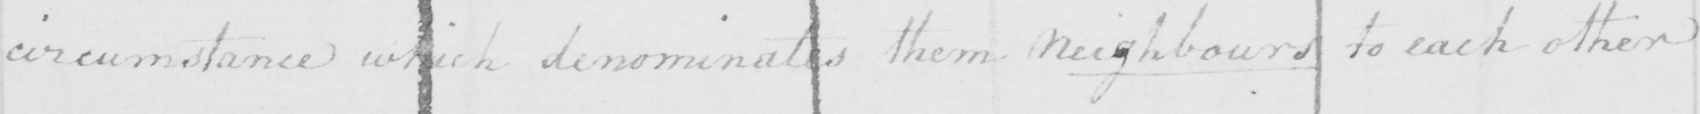Can you tell me what this handwritten text says? circumstance which denominates them neighbours to each other 